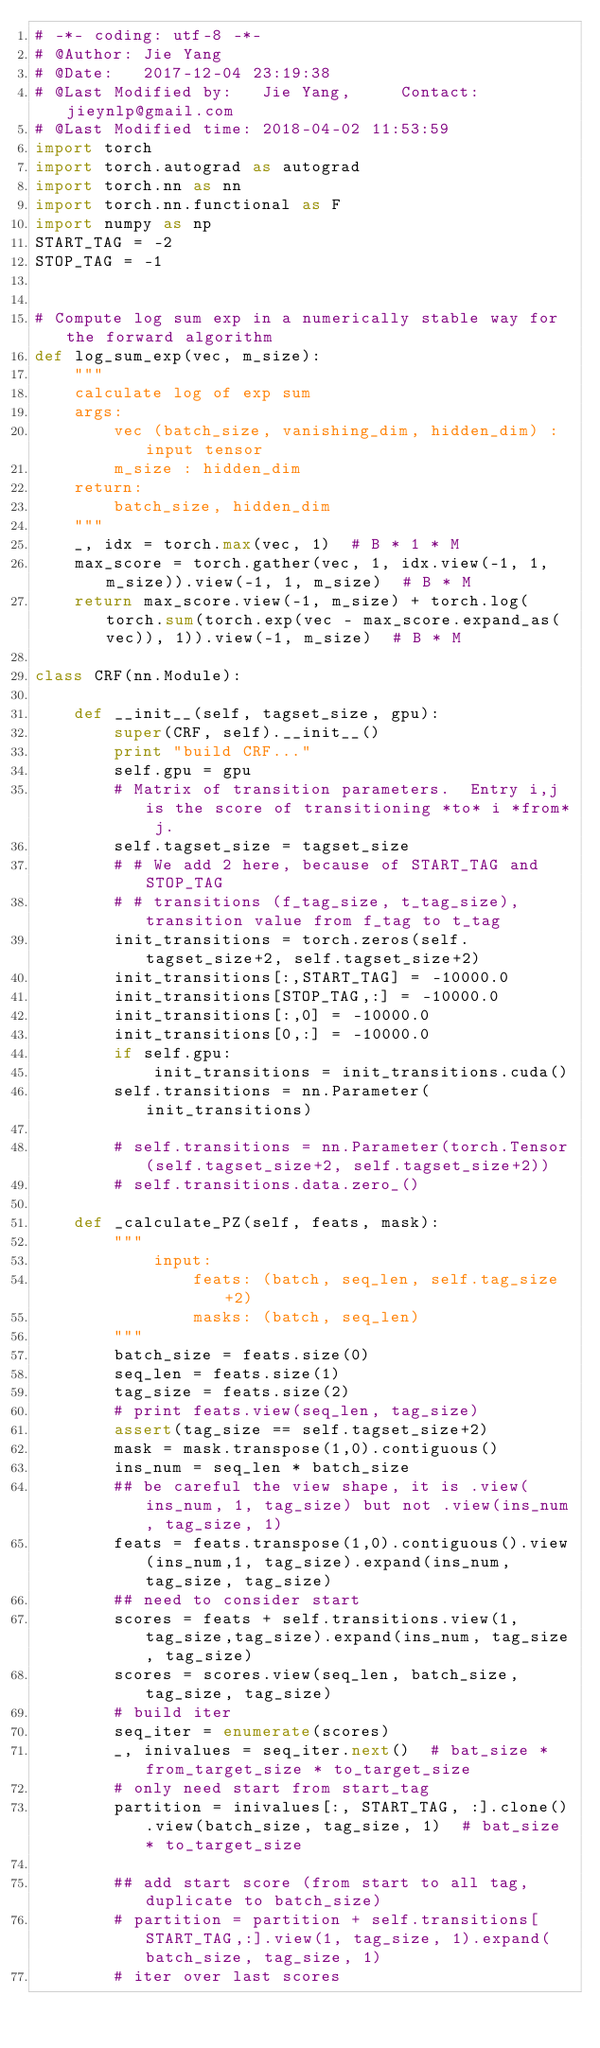Convert code to text. <code><loc_0><loc_0><loc_500><loc_500><_Python_># -*- coding: utf-8 -*-
# @Author: Jie Yang
# @Date:   2017-12-04 23:19:38
# @Last Modified by:   Jie Yang,     Contact: jieynlp@gmail.com
# @Last Modified time: 2018-04-02 11:53:59
import torch
import torch.autograd as autograd
import torch.nn as nn
import torch.nn.functional as F
import numpy as np
START_TAG = -2
STOP_TAG = -1


# Compute log sum exp in a numerically stable way for the forward algorithm
def log_sum_exp(vec, m_size):
    """
    calculate log of exp sum
    args:
        vec (batch_size, vanishing_dim, hidden_dim) : input tensor
        m_size : hidden_dim
    return:
        batch_size, hidden_dim
    """
    _, idx = torch.max(vec, 1)  # B * 1 * M
    max_score = torch.gather(vec, 1, idx.view(-1, 1, m_size)).view(-1, 1, m_size)  # B * M
    return max_score.view(-1, m_size) + torch.log(torch.sum(torch.exp(vec - max_score.expand_as(vec)), 1)).view(-1, m_size)  # B * M

class CRF(nn.Module):

    def __init__(self, tagset_size, gpu):
        super(CRF, self).__init__()
        print "build CRF..."
        self.gpu = gpu
        # Matrix of transition parameters.  Entry i,j is the score of transitioning *to* i *from* j.
        self.tagset_size = tagset_size
        # # We add 2 here, because of START_TAG and STOP_TAG
        # # transitions (f_tag_size, t_tag_size), transition value from f_tag to t_tag
        init_transitions = torch.zeros(self.tagset_size+2, self.tagset_size+2)
        init_transitions[:,START_TAG] = -10000.0
        init_transitions[STOP_TAG,:] = -10000.0
        init_transitions[:,0] = -10000.0
        init_transitions[0,:] = -10000.0
        if self.gpu:
            init_transitions = init_transitions.cuda()
        self.transitions = nn.Parameter(init_transitions)

        # self.transitions = nn.Parameter(torch.Tensor(self.tagset_size+2, self.tagset_size+2))
        # self.transitions.data.zero_()

    def _calculate_PZ(self, feats, mask):
        """
            input:
                feats: (batch, seq_len, self.tag_size+2)
                masks: (batch, seq_len)
        """
        batch_size = feats.size(0)
        seq_len = feats.size(1)
        tag_size = feats.size(2)
        # print feats.view(seq_len, tag_size)
        assert(tag_size == self.tagset_size+2)
        mask = mask.transpose(1,0).contiguous()
        ins_num = seq_len * batch_size
        ## be careful the view shape, it is .view(ins_num, 1, tag_size) but not .view(ins_num, tag_size, 1)
        feats = feats.transpose(1,0).contiguous().view(ins_num,1, tag_size).expand(ins_num, tag_size, tag_size)
        ## need to consider start
        scores = feats + self.transitions.view(1,tag_size,tag_size).expand(ins_num, tag_size, tag_size)
        scores = scores.view(seq_len, batch_size, tag_size, tag_size)
        # build iter
        seq_iter = enumerate(scores)
        _, inivalues = seq_iter.next()  # bat_size * from_target_size * to_target_size
        # only need start from start_tag
        partition = inivalues[:, START_TAG, :].clone().view(batch_size, tag_size, 1)  # bat_size * to_target_size

        ## add start score (from start to all tag, duplicate to batch_size)
        # partition = partition + self.transitions[START_TAG,:].view(1, tag_size, 1).expand(batch_size, tag_size, 1)
        # iter over last scores</code> 